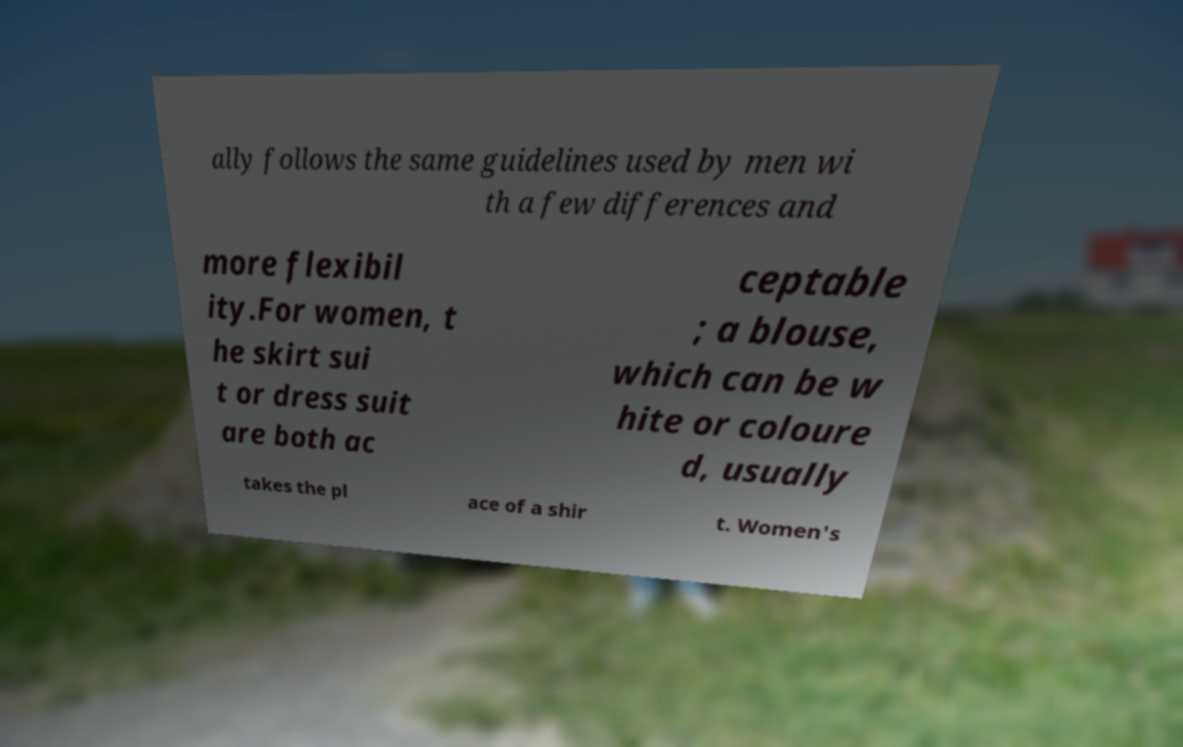Could you extract and type out the text from this image? ally follows the same guidelines used by men wi th a few differences and more flexibil ity.For women, t he skirt sui t or dress suit are both ac ceptable ; a blouse, which can be w hite or coloure d, usually takes the pl ace of a shir t. Women's 